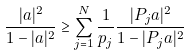Convert formula to latex. <formula><loc_0><loc_0><loc_500><loc_500>\frac { | a | ^ { 2 } } { 1 - | a | ^ { 2 } } \geq \sum _ { j = 1 } ^ { N } \frac { 1 } { p _ { j } } \frac { | P _ { j } a | ^ { 2 } } { 1 - | P _ { j } a | ^ { 2 } }</formula> 